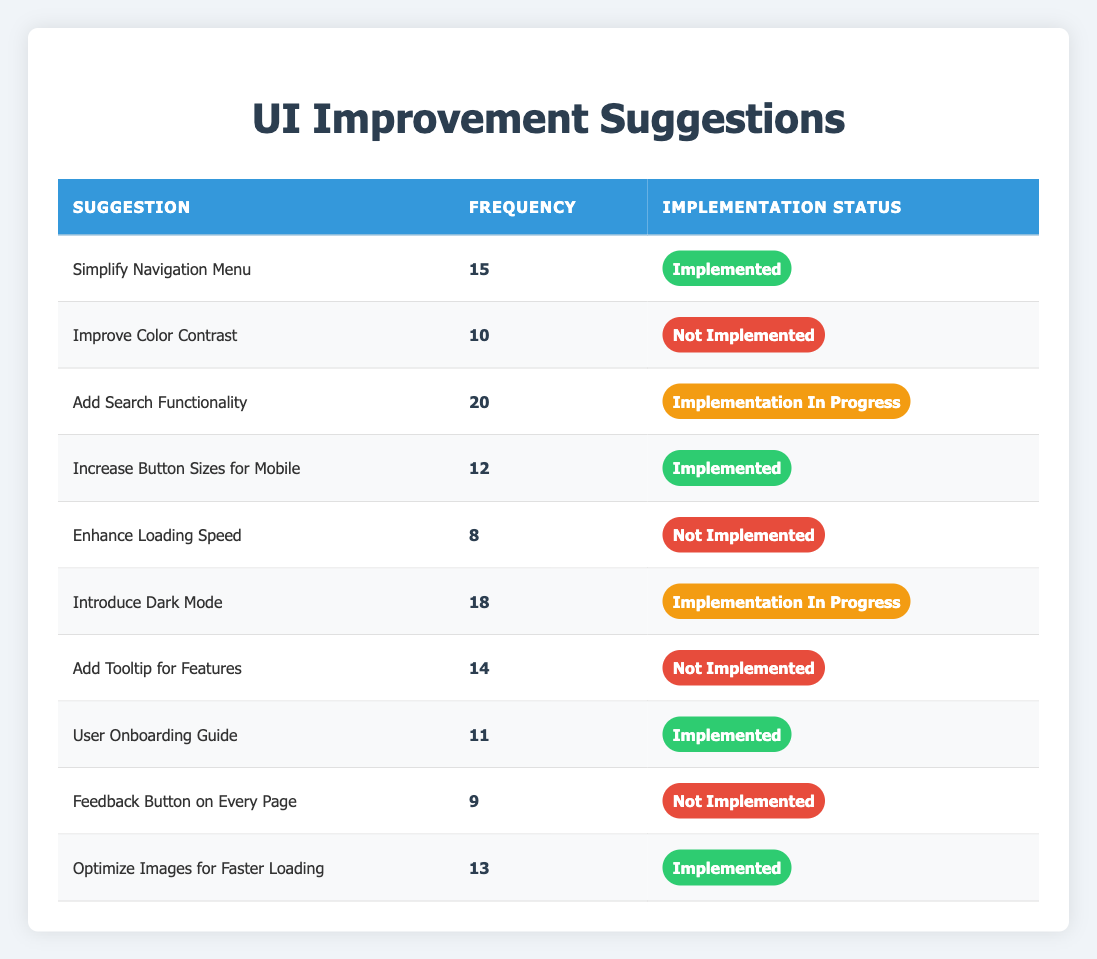What is the most frequently suggested UI improvement? The suggestion with the highest frequency in the table is "Add Search Functionality," which has a frequency of 20.
Answer: Add Search Functionality How many suggestions have been implemented? By counting the rows with the implementation status marked as "Implemented," we find there are 5 implemented suggestions.
Answer: 5 What is the frequency of the suggestion to "Introduce Dark Mode"? The table shows that the frequency of "Introduce Dark Mode" is 18.
Answer: 18 Are there any suggestions with a frequency of less than 10? Yes, the suggestion "Enhance Loading Speed" with a frequency of 8, and "Feedback Button on Every Page" with a frequency of 9 are not greater than 10.
Answer: Yes Which suggestion has the highest frequency among those that are not yet implemented? The suggestion with the highest frequency that is not implemented is "Add Tooltip for Features," which has a frequency of 14.
Answer: Add Tooltip for Features What percentage of suggestions are currently "Implementation In Progress"? There are 10 suggestions in total, and 2 of them, "Add Search Functionality" and "Introduce Dark Mode," are in progress. (2/10) * 100 = 20%.
Answer: 20% Which implemented suggestion has the lowest frequency? The implemented suggestion with the lowest frequency is "User Onboarding Guide," with a frequency of 11.
Answer: User Onboarding Guide How many suggestions are currently not implemented? By counting the suggestions marked as "Not Implemented," we see that there are 5 such suggestions in total.
Answer: 5 What is the average frequency of all implemented suggestions? The frequencies of implemented suggestions are 15, 12, 11, 13, and the sum is 71. The average frequency is 71/5 = 14.2.
Answer: 14.2 